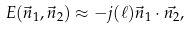<formula> <loc_0><loc_0><loc_500><loc_500>E ( \vec { n } _ { 1 } , \vec { n } _ { 2 } ) \approx - j ( \ell ) \vec { n } _ { 1 } \cdot \vec { n _ { 2 } } ,</formula> 